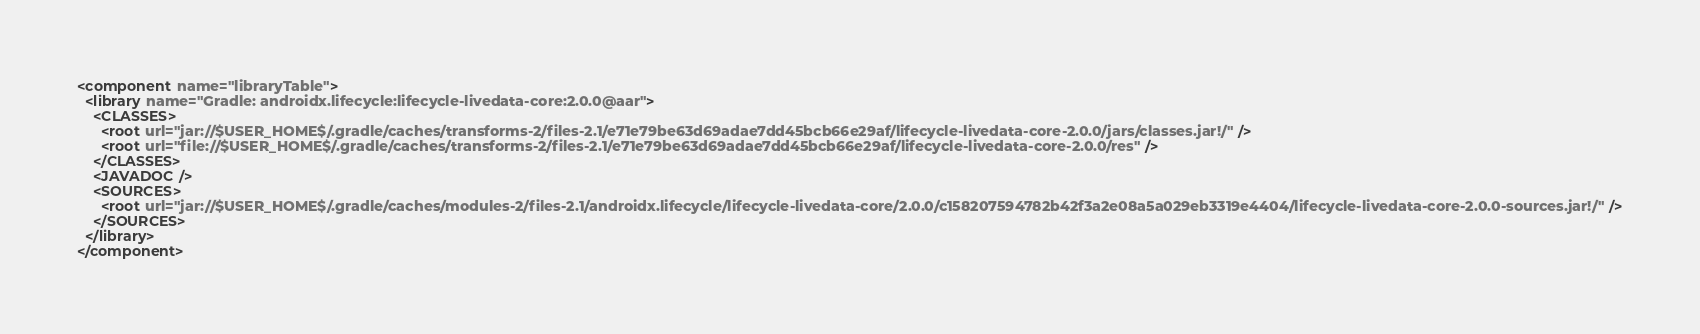Convert code to text. <code><loc_0><loc_0><loc_500><loc_500><_XML_><component name="libraryTable">
  <library name="Gradle: androidx.lifecycle:lifecycle-livedata-core:2.0.0@aar">
    <CLASSES>
      <root url="jar://$USER_HOME$/.gradle/caches/transforms-2/files-2.1/e71e79be63d69adae7dd45bcb66e29af/lifecycle-livedata-core-2.0.0/jars/classes.jar!/" />
      <root url="file://$USER_HOME$/.gradle/caches/transforms-2/files-2.1/e71e79be63d69adae7dd45bcb66e29af/lifecycle-livedata-core-2.0.0/res" />
    </CLASSES>
    <JAVADOC />
    <SOURCES>
      <root url="jar://$USER_HOME$/.gradle/caches/modules-2/files-2.1/androidx.lifecycle/lifecycle-livedata-core/2.0.0/c158207594782b42f3a2e08a5a029eb3319e4404/lifecycle-livedata-core-2.0.0-sources.jar!/" />
    </SOURCES>
  </library>
</component></code> 